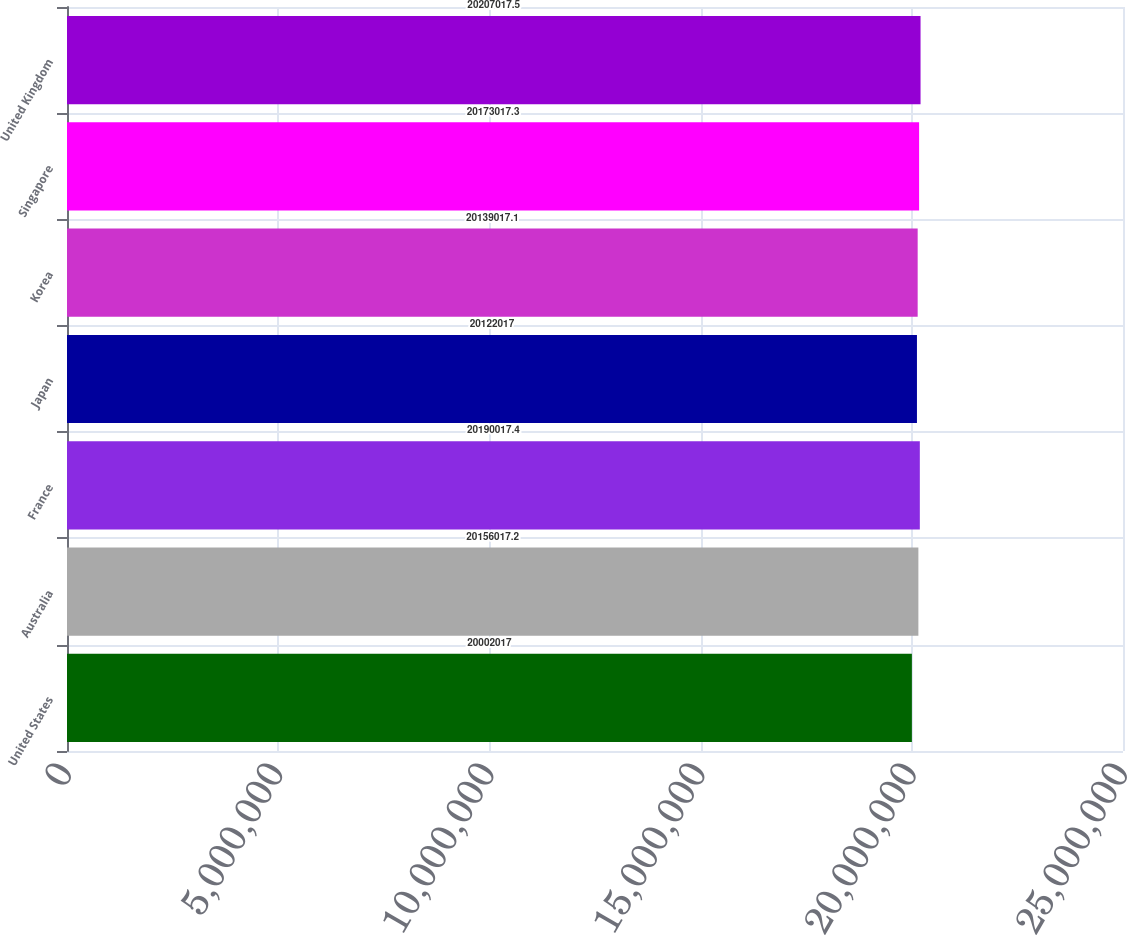Convert chart. <chart><loc_0><loc_0><loc_500><loc_500><bar_chart><fcel>United States<fcel>Australia<fcel>France<fcel>Japan<fcel>Korea<fcel>Singapore<fcel>United Kingdom<nl><fcel>2.0002e+07<fcel>2.0156e+07<fcel>2.019e+07<fcel>2.0122e+07<fcel>2.0139e+07<fcel>2.0173e+07<fcel>2.0207e+07<nl></chart> 